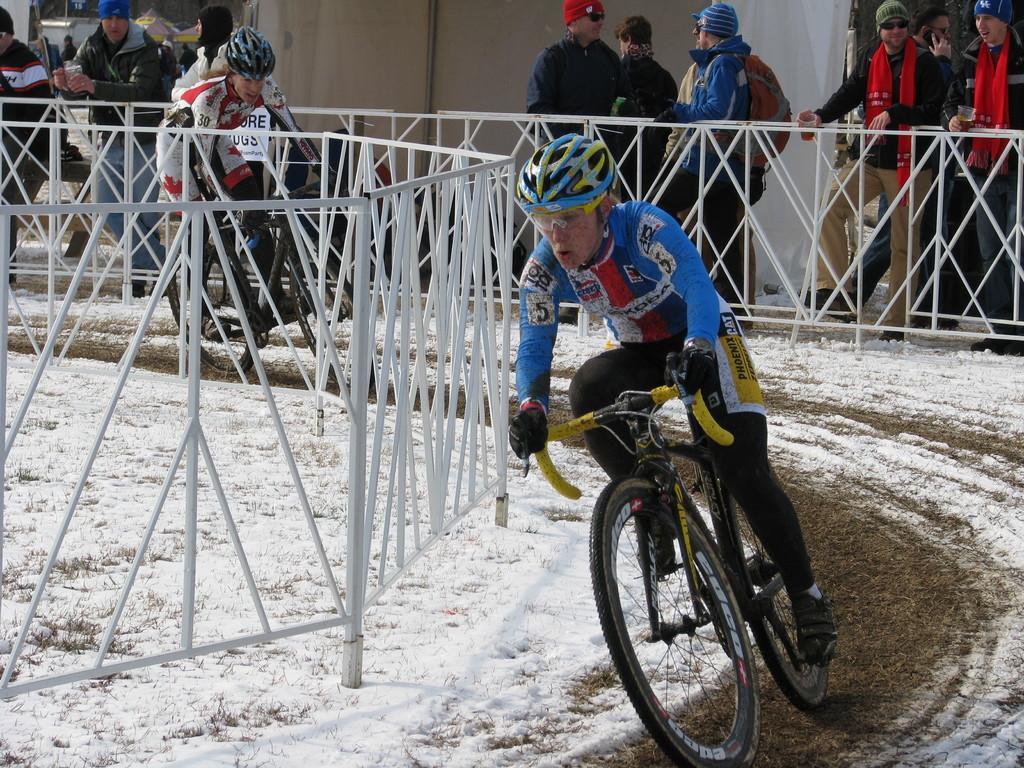Describe this image in one or two sentences. In this image I can see a person wearing blue shirt and black pant is riding a bicycle which is yellow and black in color on the ground. I can see the white railing on both sides of the ground. In the background I can see another person riding the bicycle, few persons standing, few trees and a tent which is white in color. I can see some snow on the ground. 